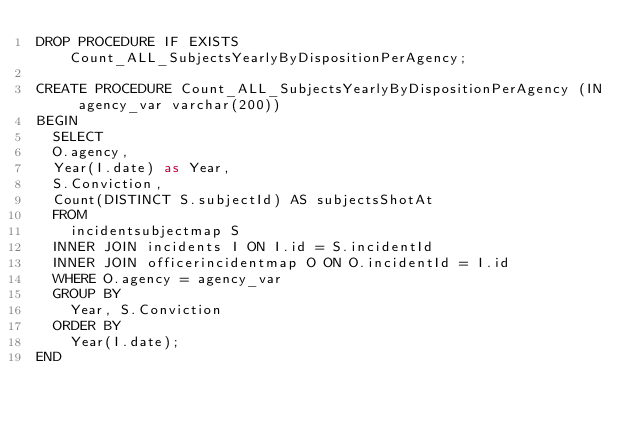Convert code to text. <code><loc_0><loc_0><loc_500><loc_500><_SQL_>DROP PROCEDURE IF EXISTS Count_ALL_SubjectsYearlyByDispositionPerAgency;

CREATE PROCEDURE Count_ALL_SubjectsYearlyByDispositionPerAgency (IN agency_var varchar(200))
BEGIN
	SELECT
	O.agency,
	Year(I.date) as Year,
	S.Conviction,
	Count(DISTINCT S.subjectId) AS subjectsShotAt
	FROM
		incidentsubjectmap S
	INNER JOIN incidents I ON I.id = S.incidentId
	INNER JOIN officerincidentmap O ON O.incidentId = I.id
	WHERE O.agency = agency_var
	GROUP BY
		Year, S.Conviction
	ORDER BY
		Year(I.date);
END</code> 